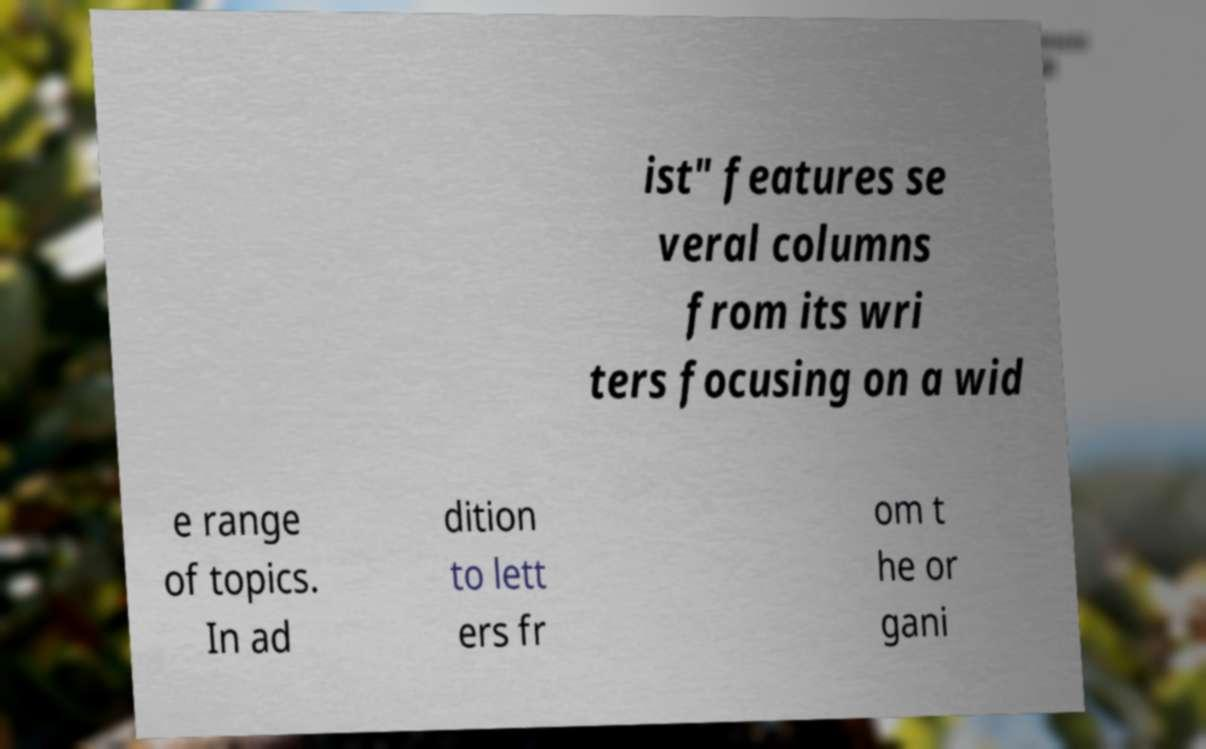What messages or text are displayed in this image? I need them in a readable, typed format. ist" features se veral columns from its wri ters focusing on a wid e range of topics. In ad dition to lett ers fr om t he or gani 